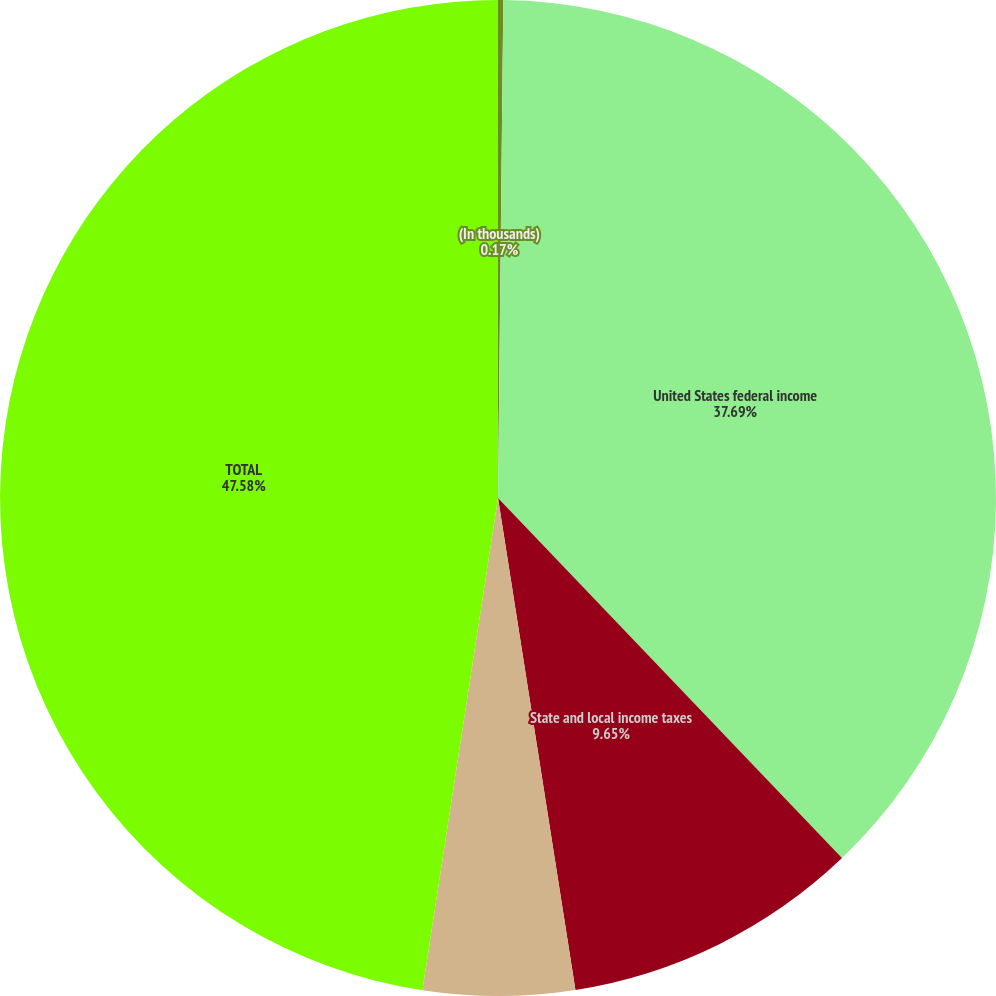Convert chart to OTSL. <chart><loc_0><loc_0><loc_500><loc_500><pie_chart><fcel>(In thousands)<fcel>United States federal income<fcel>State and local income taxes<fcel>Foreign income taxes<fcel>TOTAL<nl><fcel>0.17%<fcel>37.69%<fcel>9.65%<fcel>4.91%<fcel>47.57%<nl></chart> 